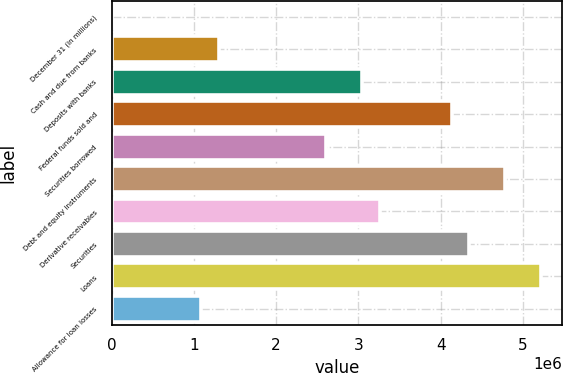<chart> <loc_0><loc_0><loc_500><loc_500><bar_chart><fcel>December 31 (in millions)<fcel>Cash and due from banks<fcel>Deposits with banks<fcel>Federal funds sold and<fcel>Securities borrowed<fcel>Debt and equity instruments<fcel>Derivative receivables<fcel>Securities<fcel>Loans<fcel>Allowance for loan losses<nl><fcel>2008<fcel>1.30583e+06<fcel>3.04427e+06<fcel>4.13079e+06<fcel>2.60966e+06<fcel>4.7827e+06<fcel>3.26157e+06<fcel>4.3481e+06<fcel>5.21731e+06<fcel>1.08853e+06<nl></chart> 